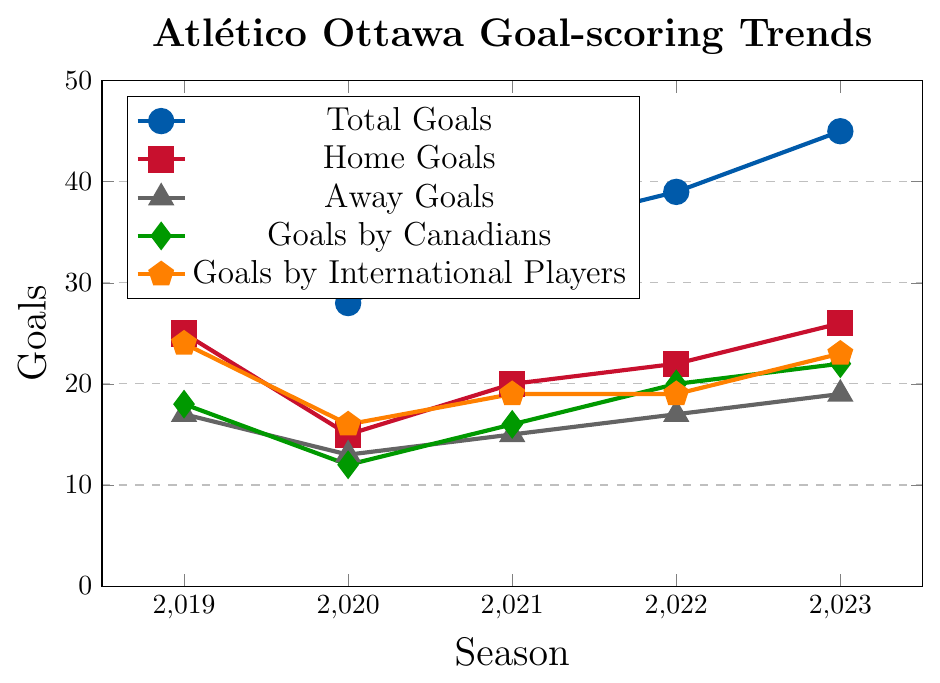What's the season with the highest total goals? Observe the blue line representing Total Goals. The highest point on this line is at 2023 with 45 goals.
Answer: 2023 What is the average number of goals scored at home over the five seasons? Add up the number of Home Goals for each season and divide by 5: (25 + 15 + 20 + 22 + 26) / 5.
Answer: 21.6 Which year shows the smallest difference between Home Goals and Away Goals? Calculate the difference for each year: 2019 (8), 2020 (2), 2021 (5), 2022 (5), 2023 (7). The smallest difference is in 2020.
Answer: 2020 Are there more goals scored by Canadians or by International Players in 2021? Compare the green line (Goals by Canadians) and the orange line (Goals by International Players) in 2021. Canadians scored 16 goals, while International Players scored 19.
Answer: International Players How many more goals did Atlético Ottawa score in 2023 compared to 2020? Subtract the total goals in 2020 from the total goals in 2023: 45 - 28.
Answer: 17 Which players scored more goals on average, Canadians or International Players? Calculate the average for both: Goals by Canadians (18+12+16+20+22)/5 = 17.6, Goals by International Players (24+16+19+19+23)/5 = 20.2. International Players average more.
Answer: International Players Which season had the closest number of Home Goals to the total number of goals? The closest ratio can be identified visually. The year 2019 had 25 Home Goals and a total of 42, with a ratio close to 1 (almost over half).
Answer: 2019 How did the number of away goals change from 2019 to 2023? Observe the gray line representing Away Goals from 2019 to 2023: 2019 (17), 2020 (13), 2021 (15), 2022 (17), 2023 (19). It fluctuated but ultimately increased by 2 goals.
Answer: Increased by 2 What's the overall trend in goals scored by Canadians from 2019 to 2023? Analyze the green line representing Goals by Canadians over the seasons: 2019 (18), 2020 (12), 2021 (16), 2022 (20), 2023 (22). It shows an upward trend.
Answer: Upward trend How many more total goals were scored in 2023 compared to 2021? Subtract the total goals in 2021 from the total goals in 2023: 45 - 35.
Answer: 10 